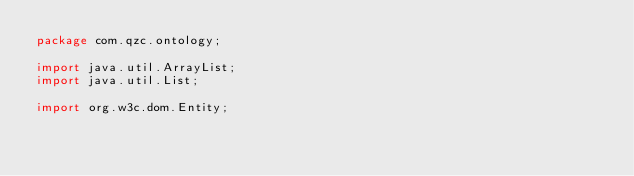<code> <loc_0><loc_0><loc_500><loc_500><_Java_>package com.qzc.ontology;

import java.util.ArrayList;
import java.util.List;

import org.w3c.dom.Entity;
</code> 